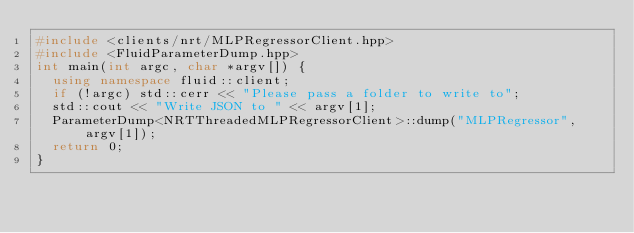<code> <loc_0><loc_0><loc_500><loc_500><_C++_>#include <clients/nrt/MLPRegressorClient.hpp>
#include <FluidParameterDump.hpp>
int main(int argc, char *argv[]) {
  using namespace fluid::client;
  if (!argc) std::cerr << "Please pass a folder to write to";
  std::cout << "Write JSON to " << argv[1];
  ParameterDump<NRTThreadedMLPRegressorClient>::dump("MLPRegressor", argv[1]);
  return 0;
}
</code> 